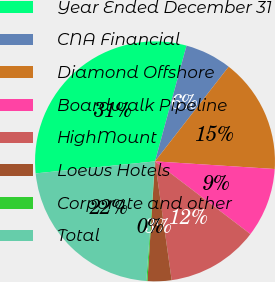Convert chart. <chart><loc_0><loc_0><loc_500><loc_500><pie_chart><fcel>Year Ended December 31<fcel>CNA Financial<fcel>Diamond Offshore<fcel>Boardwalk Pipeline<fcel>HighMount<fcel>Loews Hotels<fcel>Corporate and other<fcel>Total<nl><fcel>30.83%<fcel>6.29%<fcel>15.49%<fcel>9.35%<fcel>12.42%<fcel>3.22%<fcel>0.15%<fcel>22.25%<nl></chart> 